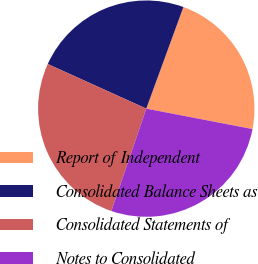Convert chart to OTSL. <chart><loc_0><loc_0><loc_500><loc_500><pie_chart><fcel>Report of Independent<fcel>Consolidated Balance Sheets as<fcel>Consolidated Statements of<fcel>Notes to Consolidated<nl><fcel>22.45%<fcel>23.81%<fcel>26.53%<fcel>27.21%<nl></chart> 